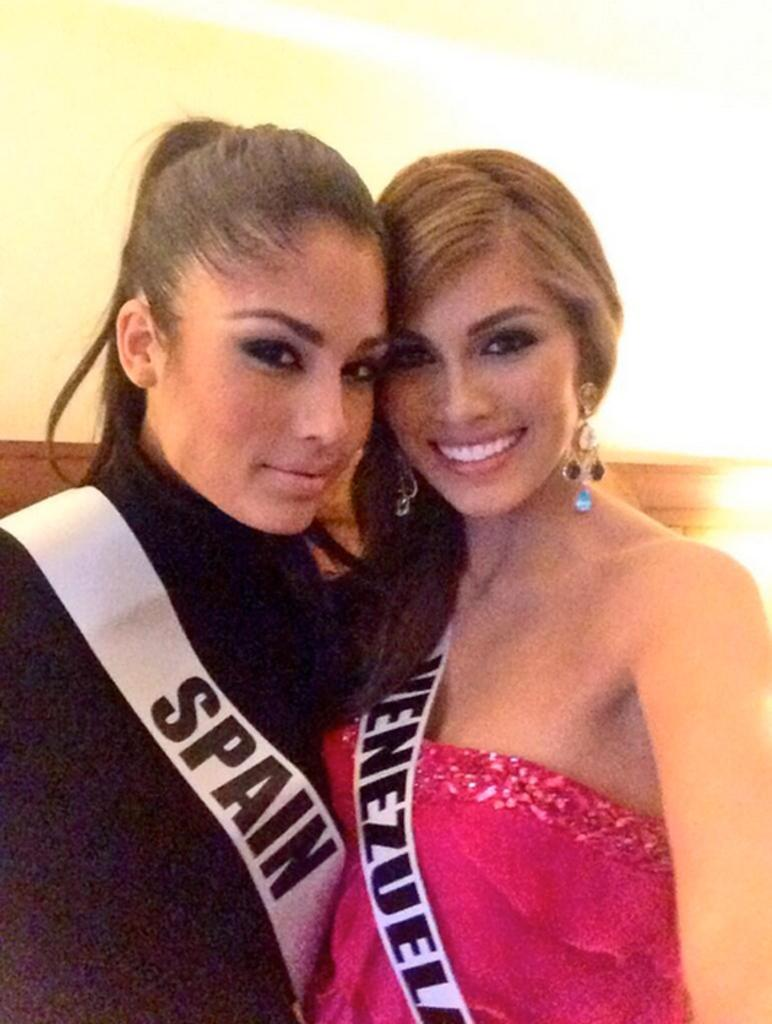<image>
Describe the image concisely. A sash with the word spain is hanging off a woman in a black top. 